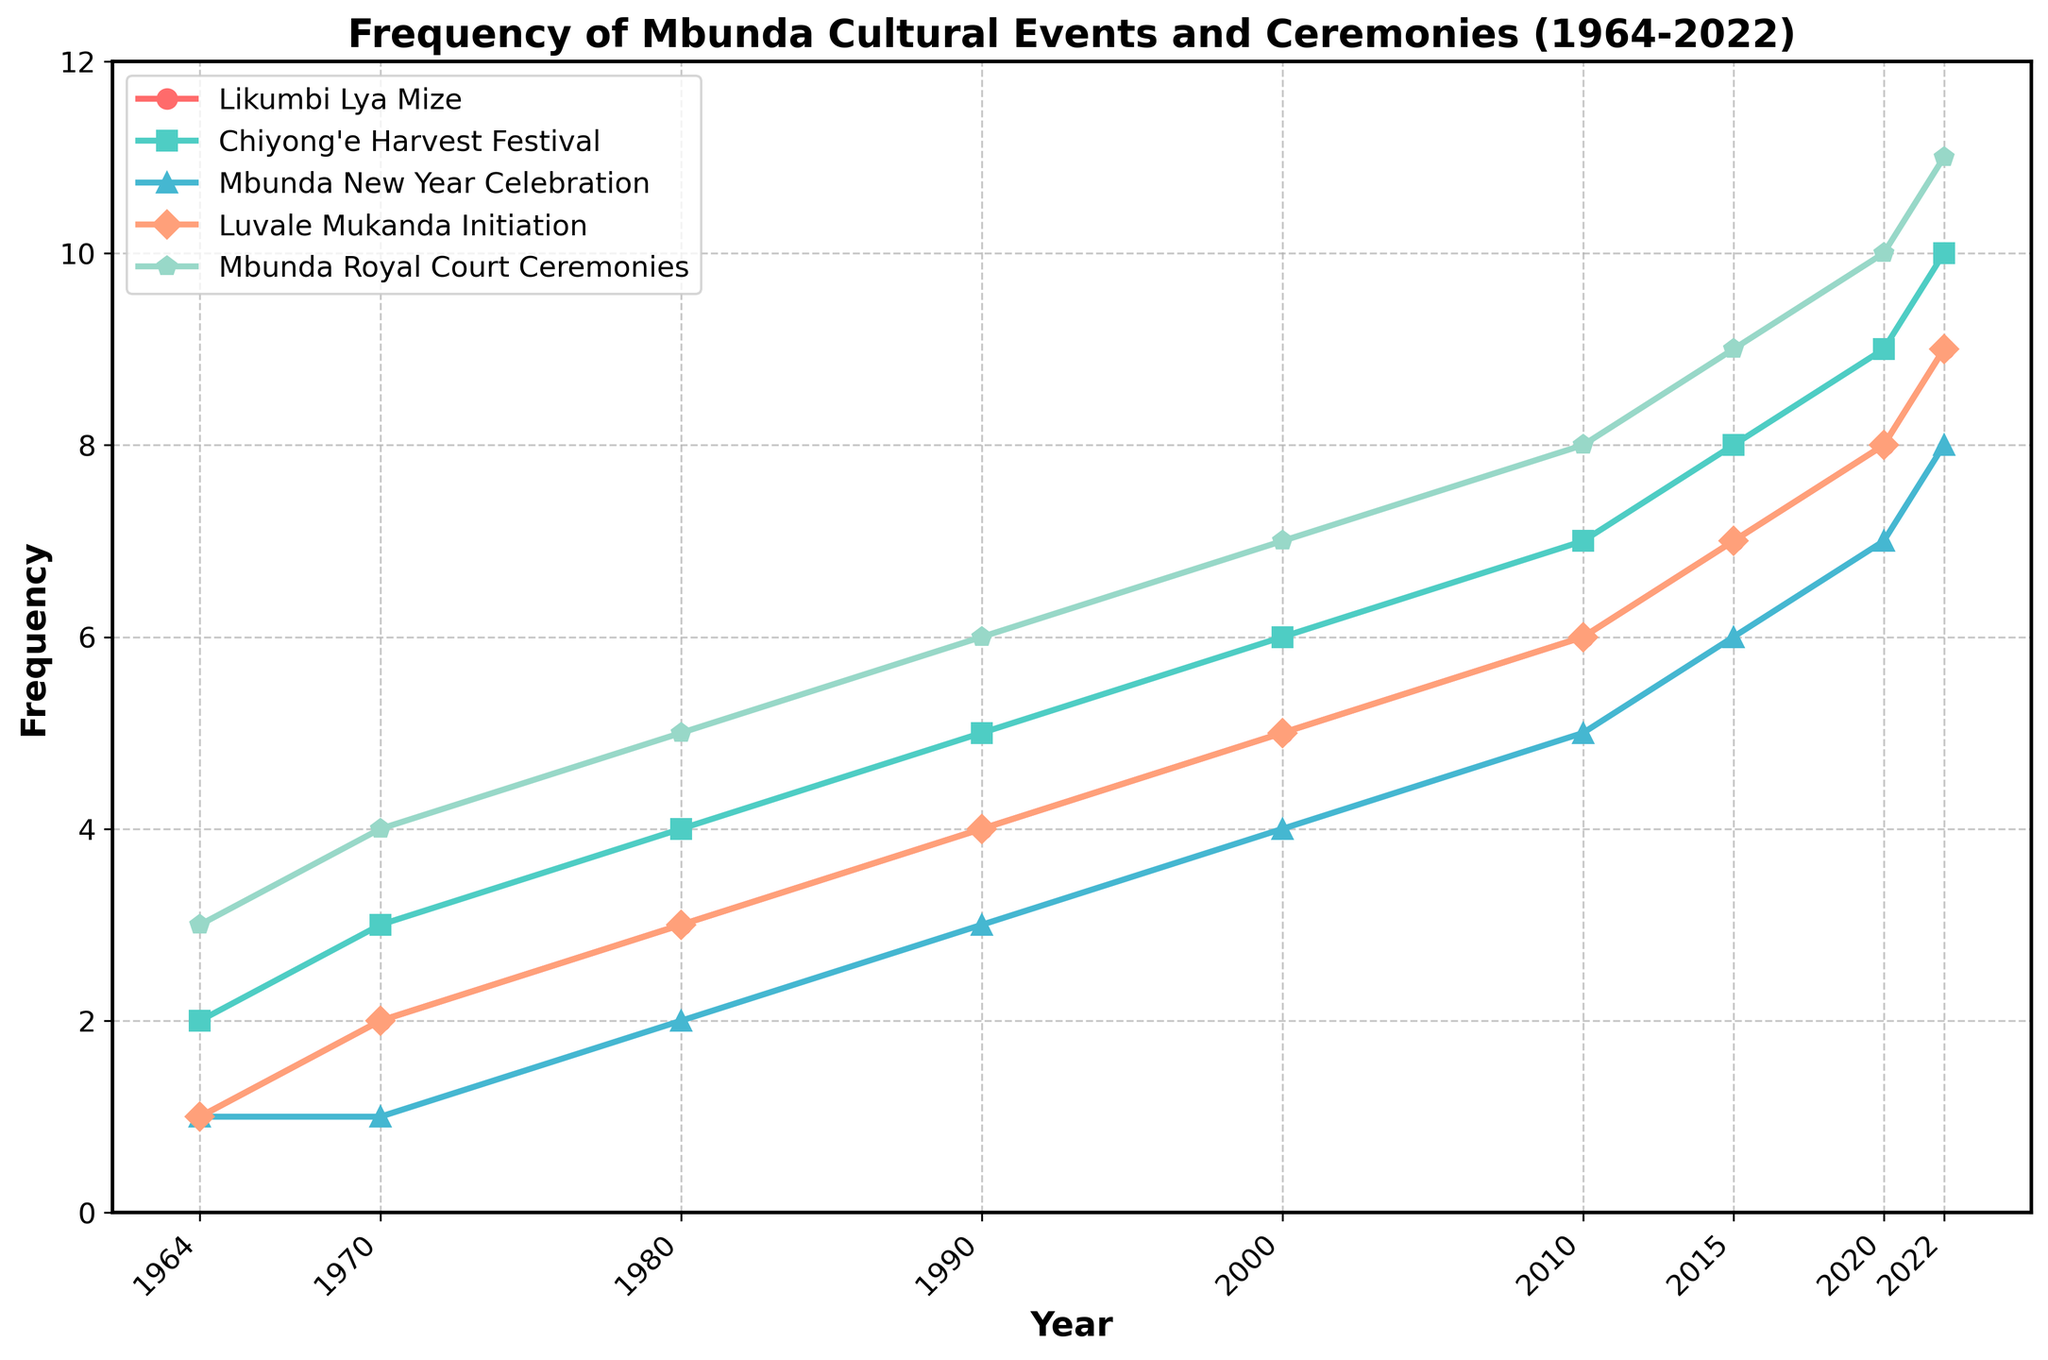What is the trend of the Mbunda New Year Celebration from 1964 to 2022? The frequency increases steadily from 1 event in 1964 to 8 events in 2022 without any drops or stagnations.
Answer: Steady increase Which event had the highest frequency in 2022? By observing the heights of the lines for the year 2022, the Mbunda Royal Court Ceremonies have the highest frequency of 11.
Answer: Mbunda Royal Court Ceremonies Between which two consecutive decades did the Likumbi Lya Mize show the largest increase in frequency? Compare the differences between each decade: 
1964-1970: 2-1=1 
1970-1980: 3-2=1 
1980-1990: 4-3=1 
1990-2000: 5-4=1 
2000-2010: 6-5=1 
2010-2015: 7-6=1 
2015-2020: 8-7=1 
2010-2025: 9-8=1 
All increases are equal.
Answer: No specific decade What is the average frequency of the Chiyong'e Harvest Festival between 1964 and 2022? Sum of the frequencies = 2+3+4+5+6+7+8+9+10 = 54. There are 9 data points, so the average is 54 / 9 = 6.
Answer: 6 Which event had a constant rate of increase over the years? By observing the gradient of each event's line, the Likumbi Lya Mize shows a constant rate of increase, with each period it increases exactly by 1.
Answer: Likumbi Lya Mize Is the frequency of the Luvale Mukanda Initiation higher than the Mbunda New Year Celebration in 2010? By comparing the heights at the year 2010, Luvale Mukanda Initiation is at 6, while Mbunda New Year Celebration is at 5.
Answer: Yes How many total events were recorded in the year 2000? Sum the frequencies of all events in 2000: 5+6+4+5+7=27.
Answer: 27 Which event showed the largest increase in frequency between 1964 and 2022? By comparing the difference from 1964 to 2022 for each event:
Likumbi Lya Mize: 9-1=8 
Chiyong'e Harvest Festival: 2-10=8 
Mbunda New Year Celebration: 8-1=7 
Luvale Mukanda Initiation: 9-1=8 
Mbunda Royal Court Ceremonies: 11-3=8 
Three events (Likumbi Lya Mize, Chiyong'e Harvest Festival, and Luvale Mukanda Initiation) showed the largest increase of 8.
Answer: Likumbi Lya Mize, Chiyong'e Harvest Festival, and Luvale Mukanda Initiation Which event has consistently been the most frequently held over the years? By looking at the trends, the Mbunda Royal Court Ceremonies start at a higher frequency and maintain the top position consistently.
Answer: Mbunda Royal Court Ceremonies Among the five events, which two events have the closest frequencies in the year 2020? By looking at the values in 2020: 
Likumbi Lya Mize: 8 
Chiyong'e Harvest Festival: 9 
Mbunda New Year Celebration: 7 
Luvale Mukanda Initiation: 8 
Mbunda Royal Court Ceremonies: 10 
The Likumbi Lya Mize and Luvale Mukanda Initiation both have a frequency of 8, making them the closest.
Answer: Likumbi Lya Mize and Luvale Mukanda Initiation 